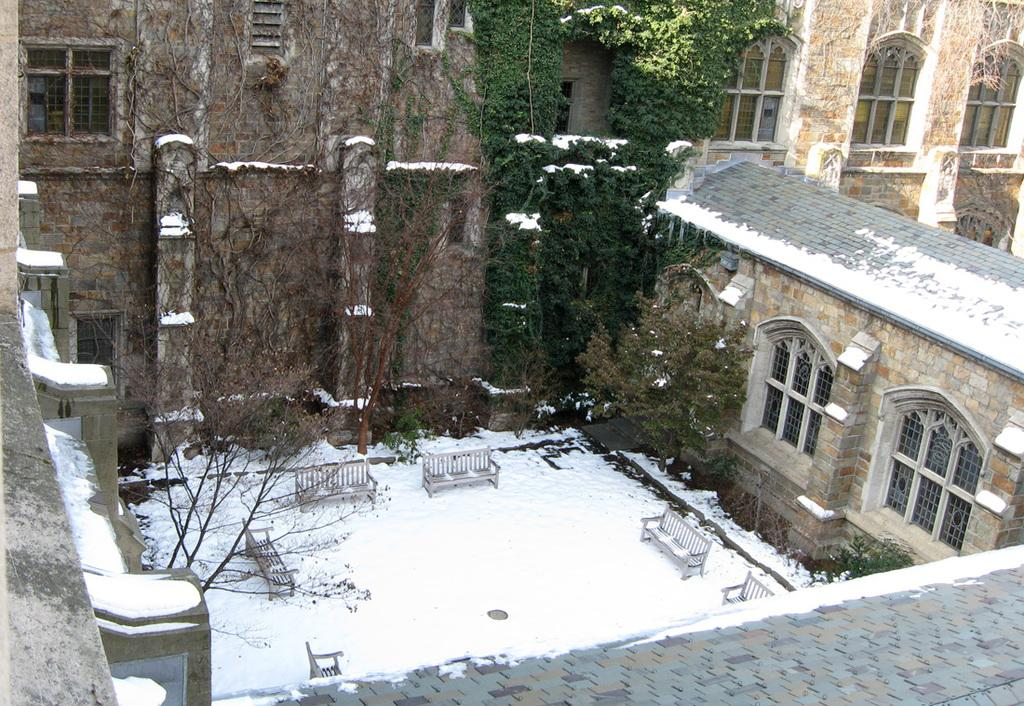What type of structure is visible in the image? There is a building with windows in the image. What can be found near the building? There are benches and trees visible in the image. What is the weather like in the image? The image appears to depict snow, suggesting a cold and wintry environment. How is the building affected by the snow? The roof of the building is partially covered with snow. What rhythm is the father playing on the mine in the image? There is no father, mine, or rhythm present in the image. 